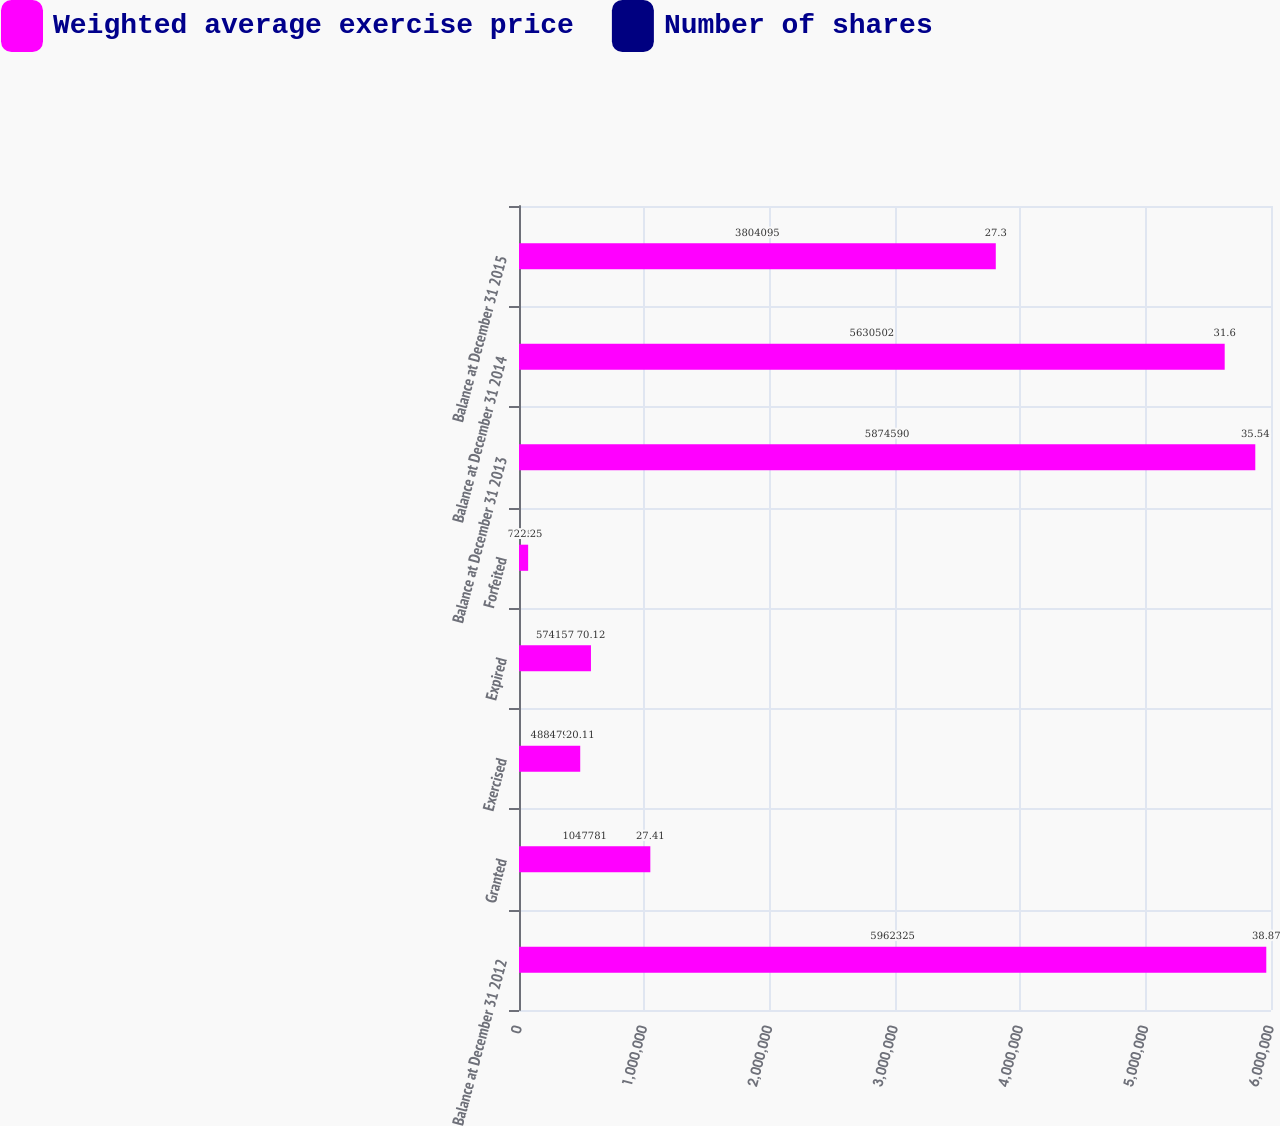Convert chart to OTSL. <chart><loc_0><loc_0><loc_500><loc_500><stacked_bar_chart><ecel><fcel>Balance at December 31 2012<fcel>Granted<fcel>Exercised<fcel>Expired<fcel>Forfeited<fcel>Balance at December 31 2013<fcel>Balance at December 31 2014<fcel>Balance at December 31 2015<nl><fcel>Weighted average exercise price<fcel>5.96232e+06<fcel>1.04778e+06<fcel>488479<fcel>574157<fcel>72880<fcel>5.87459e+06<fcel>5.6305e+06<fcel>3.8041e+06<nl><fcel>Number of shares<fcel>38.87<fcel>27.41<fcel>20.11<fcel>70.12<fcel>22.25<fcel>35.54<fcel>31.6<fcel>27.3<nl></chart> 